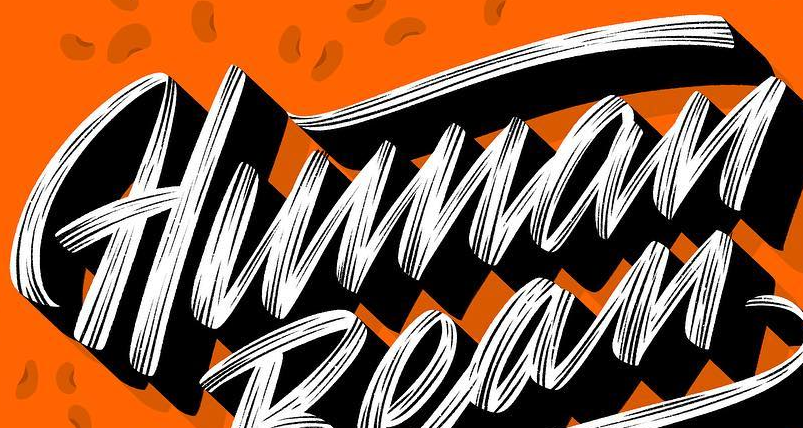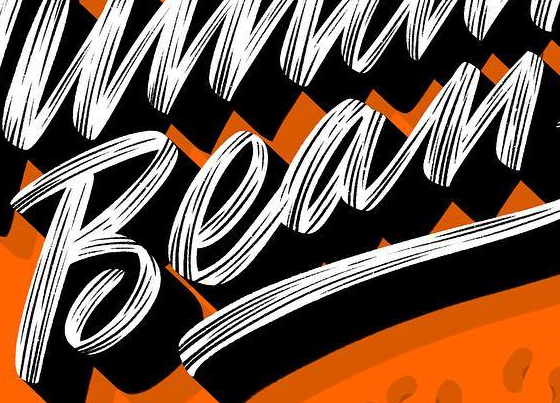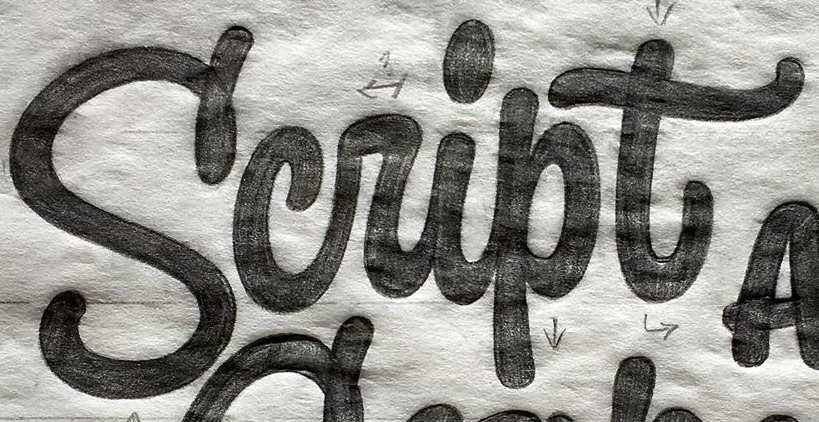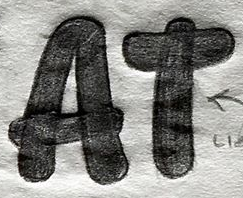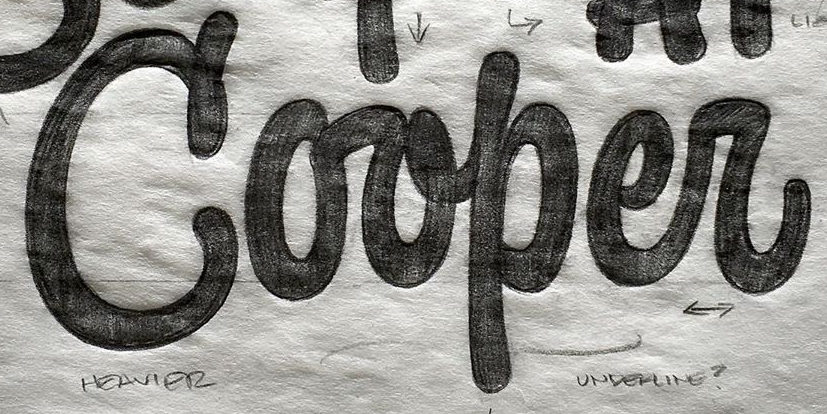Identify the words shown in these images in order, separated by a semicolon. Human; Bean; Script; AT; Corper 